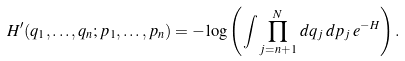<formula> <loc_0><loc_0><loc_500><loc_500>H ^ { \prime } ( q _ { 1 } , \dots , q _ { n } ; p _ { 1 } , \dots , p _ { n } ) = - \log \left ( \int \prod _ { j = n + 1 } ^ { N } \, d q _ { j } \, d p _ { j } \, e ^ { - H } \right ) .</formula> 